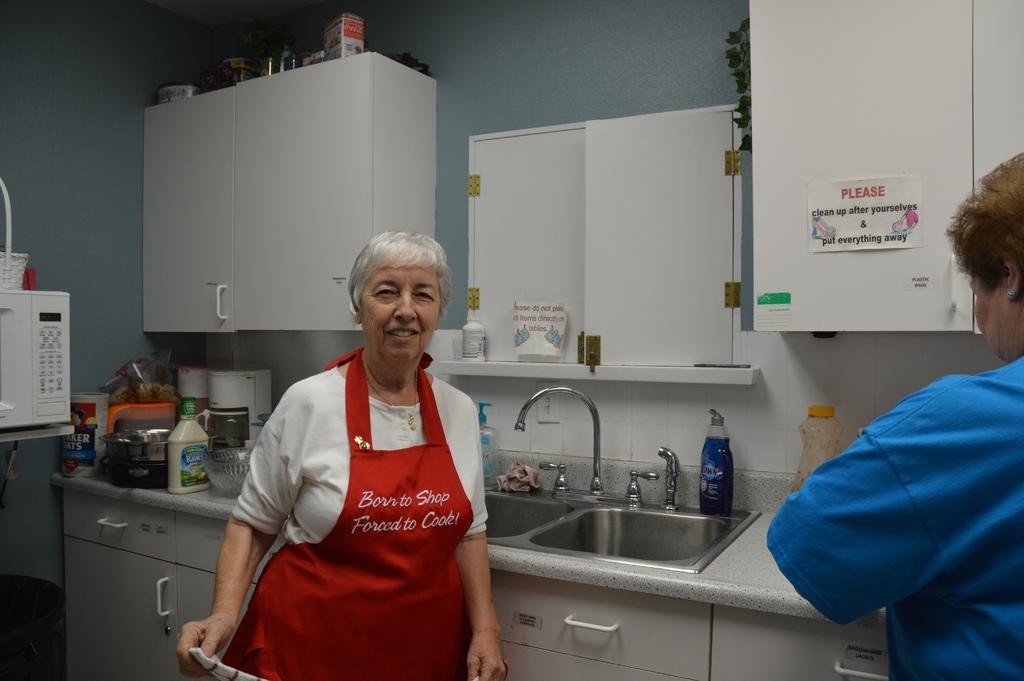<image>
Offer a succinct explanation of the picture presented. An older woman with Born to Shop Forced to Cook on her red apron stands by a sink. 